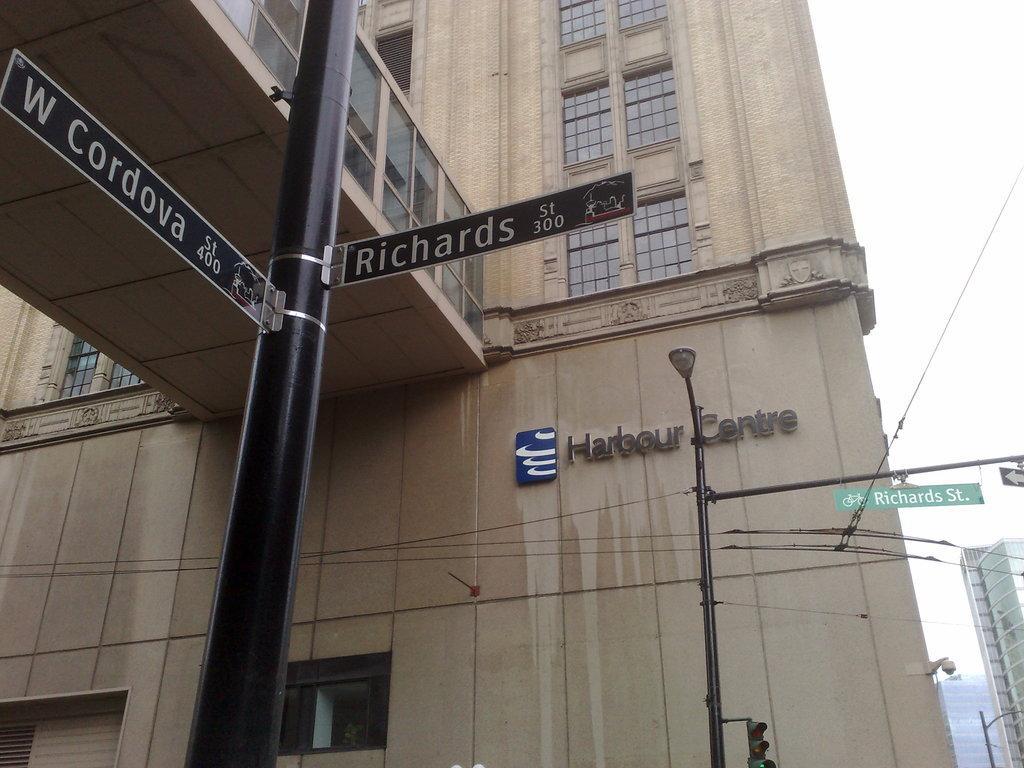How would you summarize this image in a sentence or two? In this image there is a building, in front of the building there is a pole with sign board and street light. On the right side of the image there are buildings. In the background there is the sky. 